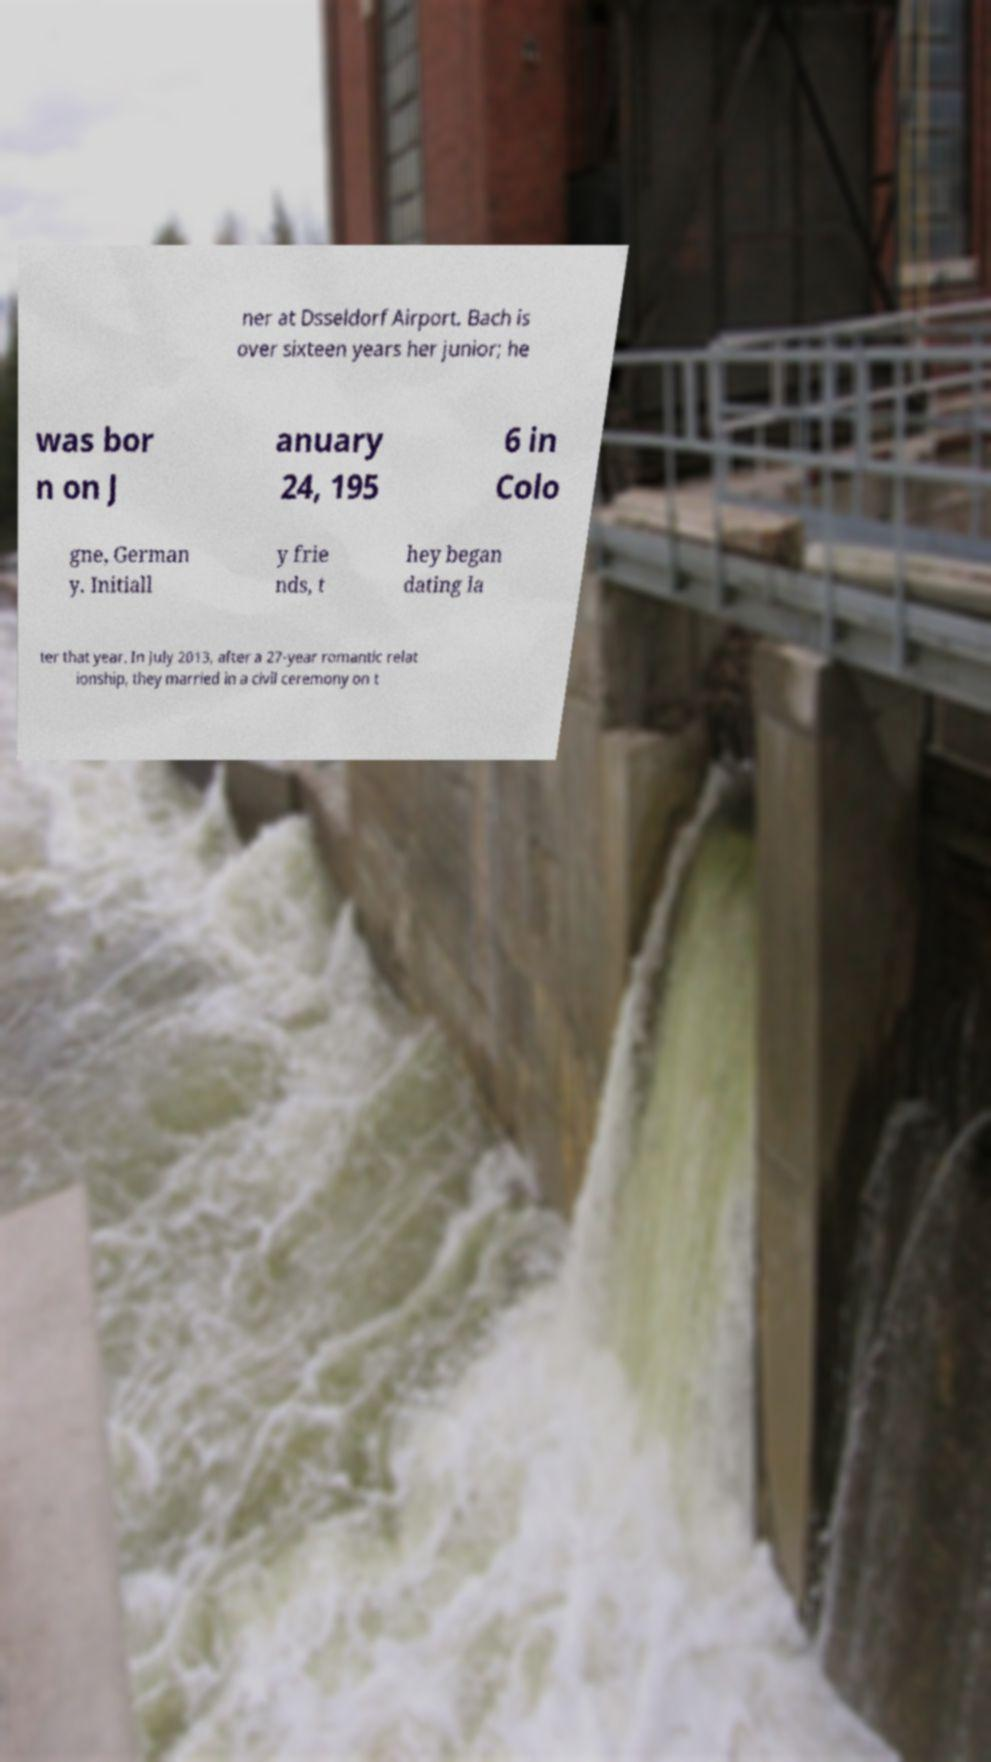I need the written content from this picture converted into text. Can you do that? ner at Dsseldorf Airport. Bach is over sixteen years her junior; he was bor n on J anuary 24, 195 6 in Colo gne, German y. Initiall y frie nds, t hey began dating la ter that year. In July 2013, after a 27-year romantic relat ionship, they married in a civil ceremony on t 